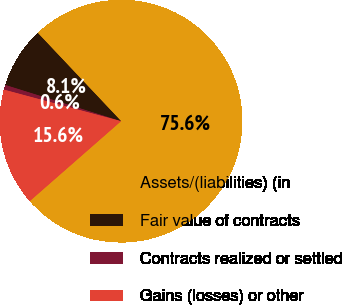<chart> <loc_0><loc_0><loc_500><loc_500><pie_chart><fcel>Assets/(liabilities) (in<fcel>Fair value of contracts<fcel>Contracts realized or settled<fcel>Gains (losses) or other<nl><fcel>75.6%<fcel>8.13%<fcel>0.64%<fcel>15.63%<nl></chart> 